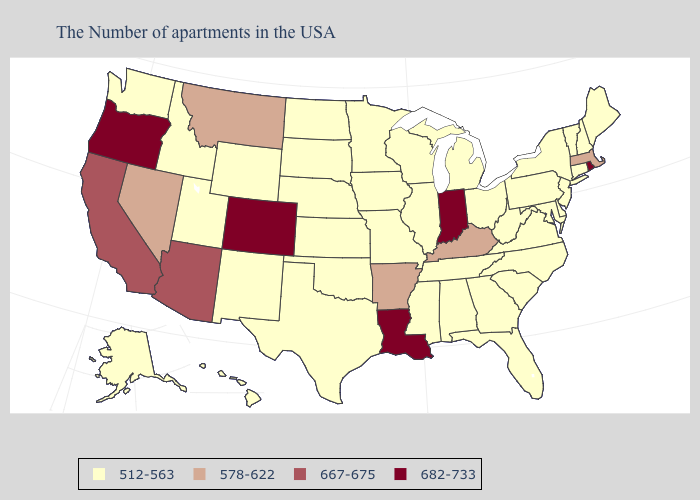Among the states that border Louisiana , does Texas have the lowest value?
Short answer required. Yes. What is the value of Idaho?
Be succinct. 512-563. What is the value of Georgia?
Be succinct. 512-563. Name the states that have a value in the range 512-563?
Give a very brief answer. Maine, New Hampshire, Vermont, Connecticut, New York, New Jersey, Delaware, Maryland, Pennsylvania, Virginia, North Carolina, South Carolina, West Virginia, Ohio, Florida, Georgia, Michigan, Alabama, Tennessee, Wisconsin, Illinois, Mississippi, Missouri, Minnesota, Iowa, Kansas, Nebraska, Oklahoma, Texas, South Dakota, North Dakota, Wyoming, New Mexico, Utah, Idaho, Washington, Alaska, Hawaii. What is the value of Colorado?
Keep it brief. 682-733. Is the legend a continuous bar?
Give a very brief answer. No. Is the legend a continuous bar?
Short answer required. No. What is the value of Nevada?
Write a very short answer. 578-622. What is the value of New Hampshire?
Concise answer only. 512-563. Does Arkansas have the same value as Massachusetts?
Be succinct. Yes. Which states hav the highest value in the MidWest?
Keep it brief. Indiana. Name the states that have a value in the range 667-675?
Quick response, please. Arizona, California. Name the states that have a value in the range 512-563?
Write a very short answer. Maine, New Hampshire, Vermont, Connecticut, New York, New Jersey, Delaware, Maryland, Pennsylvania, Virginia, North Carolina, South Carolina, West Virginia, Ohio, Florida, Georgia, Michigan, Alabama, Tennessee, Wisconsin, Illinois, Mississippi, Missouri, Minnesota, Iowa, Kansas, Nebraska, Oklahoma, Texas, South Dakota, North Dakota, Wyoming, New Mexico, Utah, Idaho, Washington, Alaska, Hawaii. What is the value of Texas?
Give a very brief answer. 512-563. Does Louisiana have the highest value in the South?
Short answer required. Yes. 